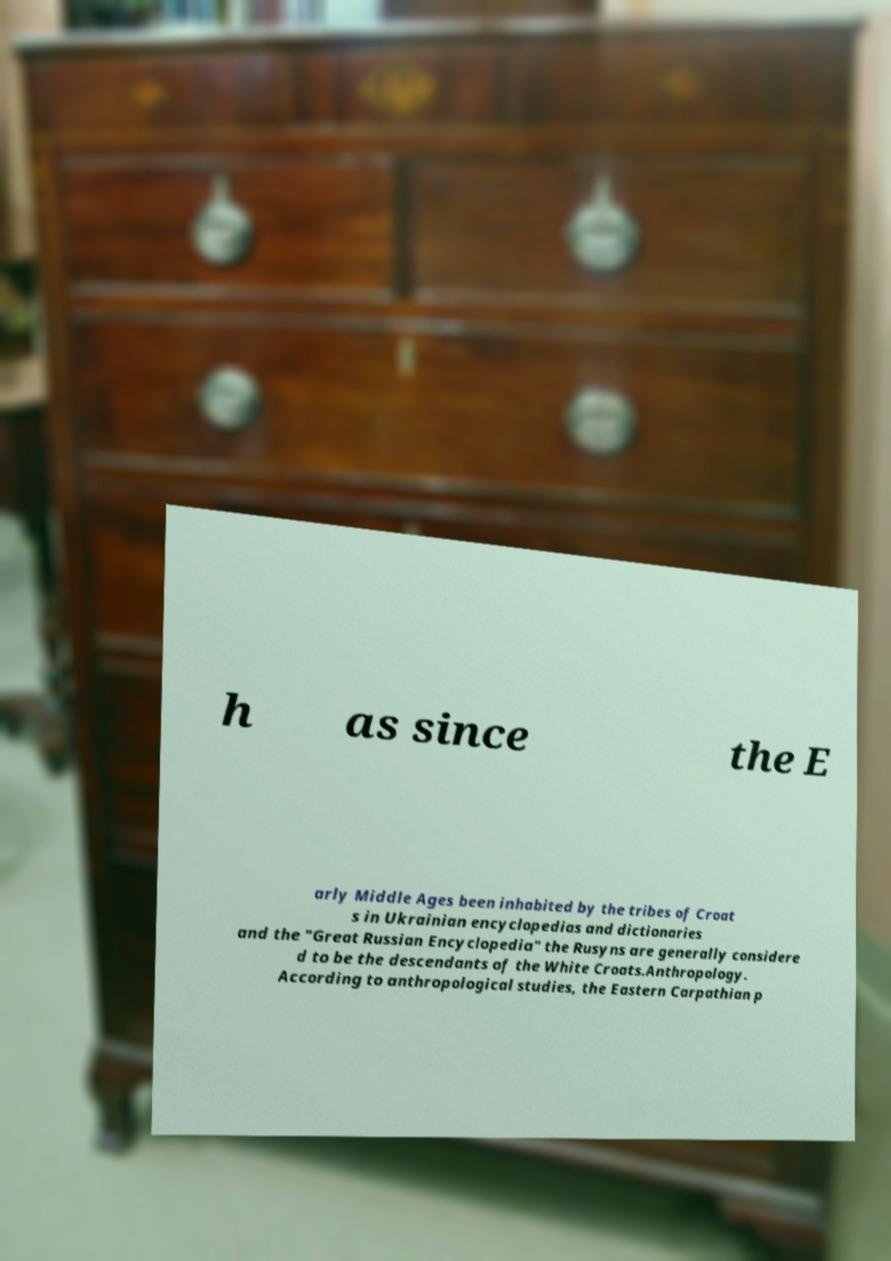Can you read and provide the text displayed in the image?This photo seems to have some interesting text. Can you extract and type it out for me? h as since the E arly Middle Ages been inhabited by the tribes of Croat s in Ukrainian encyclopedias and dictionaries and the "Great Russian Encyclopedia" the Rusyns are generally considere d to be the descendants of the White Croats.Anthropology. According to anthropological studies, the Eastern Carpathian p 